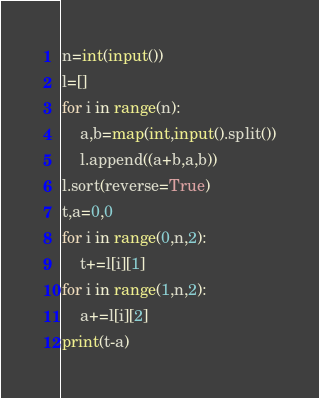Convert code to text. <code><loc_0><loc_0><loc_500><loc_500><_Python_>n=int(input())
l=[]
for i in range(n):
    a,b=map(int,input().split())
    l.append((a+b,a,b))
l.sort(reverse=True)
t,a=0,0
for i in range(0,n,2):
    t+=l[i][1]
for i in range(1,n,2):
    a+=l[i][2]
print(t-a)</code> 